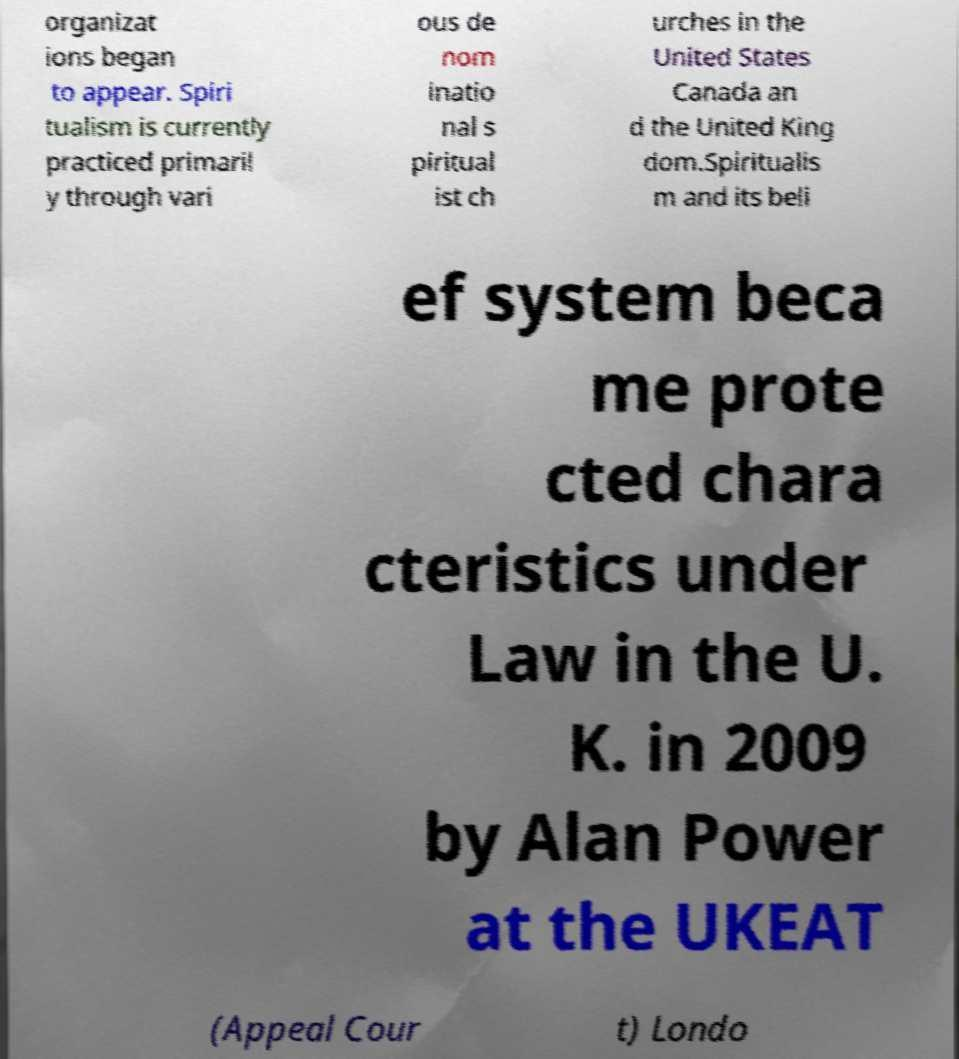Can you read and provide the text displayed in the image?This photo seems to have some interesting text. Can you extract and type it out for me? organizat ions began to appear. Spiri tualism is currently practiced primaril y through vari ous de nom inatio nal s piritual ist ch urches in the United States Canada an d the United King dom.Spiritualis m and its beli ef system beca me prote cted chara cteristics under Law in the U. K. in 2009 by Alan Power at the UKEAT (Appeal Cour t) Londo 